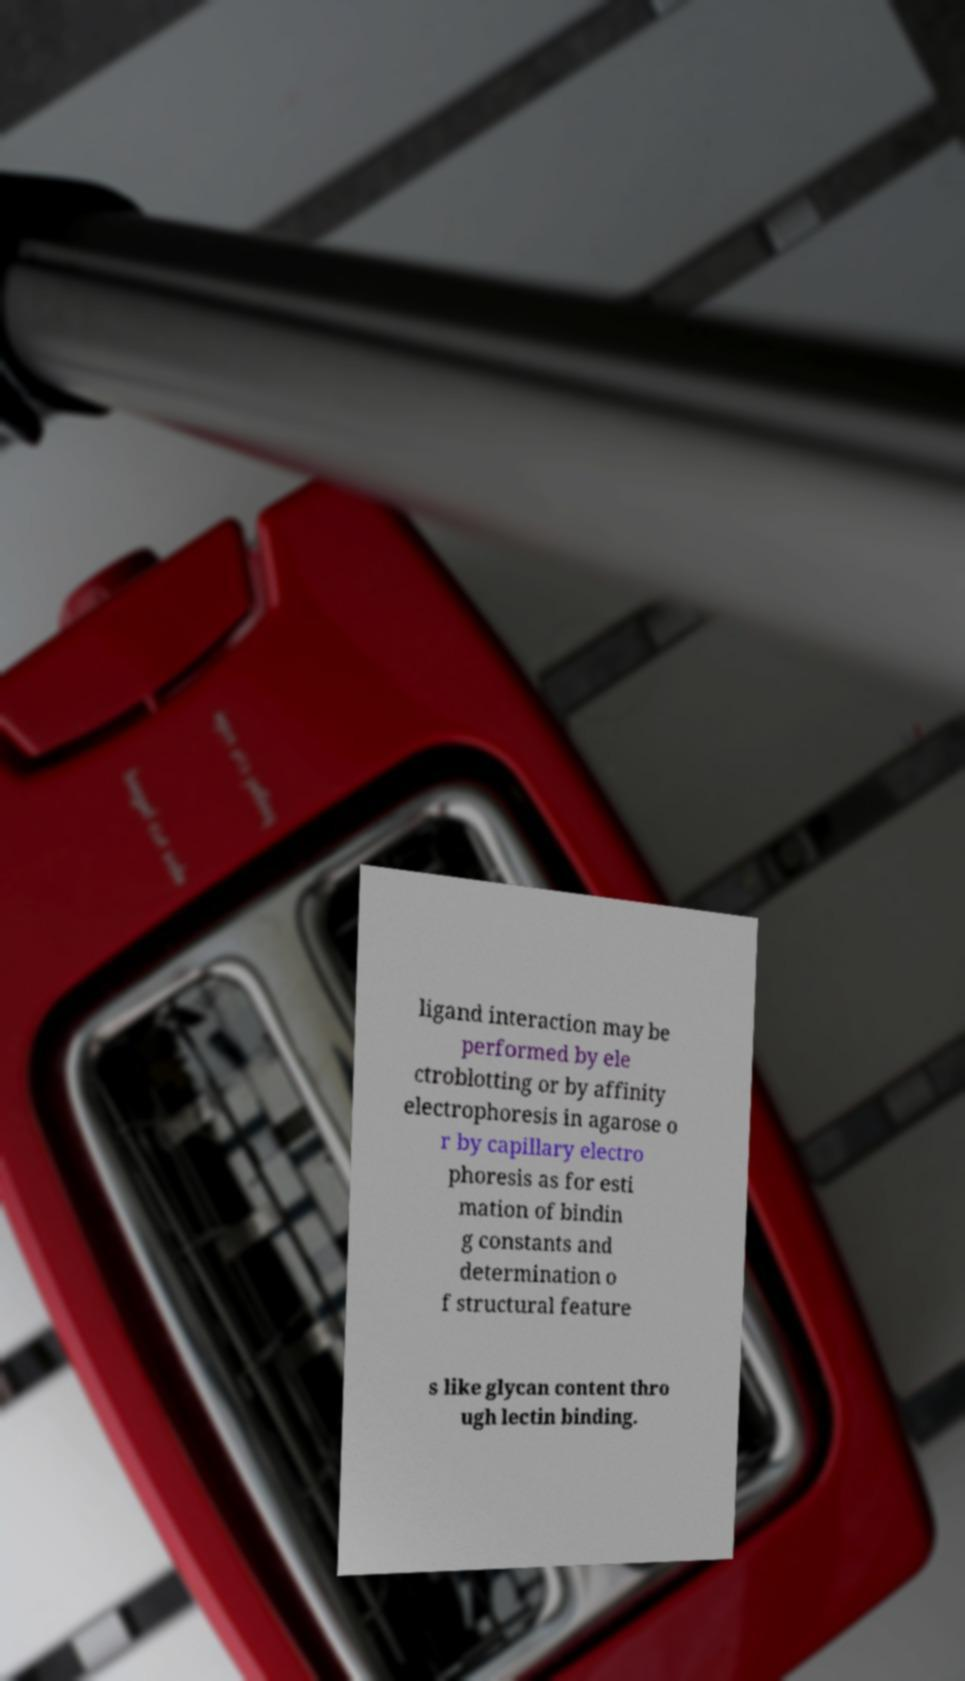I need the written content from this picture converted into text. Can you do that? ligand interaction may be performed by ele ctroblotting or by affinity electrophoresis in agarose o r by capillary electro phoresis as for esti mation of bindin g constants and determination o f structural feature s like glycan content thro ugh lectin binding. 